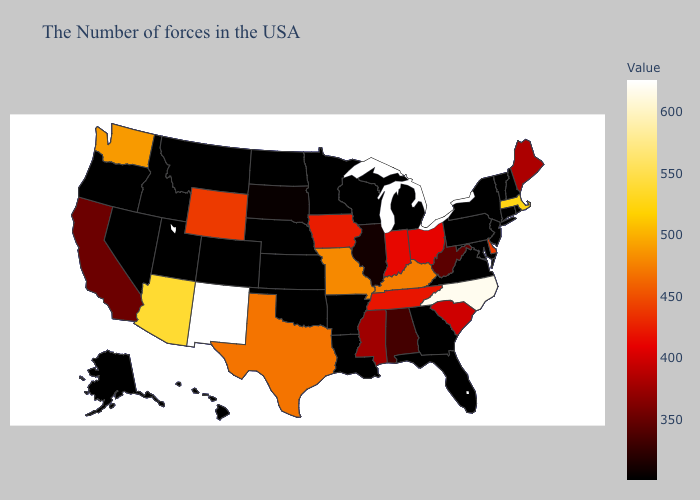Does Maine have the lowest value in the Northeast?
Write a very short answer. No. Does South Carolina have a lower value than Vermont?
Be succinct. No. Among the states that border New Jersey , which have the highest value?
Concise answer only. Delaware. Does Mississippi have a higher value than Oklahoma?
Concise answer only. Yes. Among the states that border Maryland , which have the highest value?
Short answer required. Delaware. Which states have the lowest value in the USA?
Be succinct. Rhode Island, New Hampshire, Vermont, Connecticut, New York, New Jersey, Maryland, Pennsylvania, Virginia, Florida, Georgia, Michigan, Wisconsin, Louisiana, Arkansas, Minnesota, Kansas, Nebraska, Oklahoma, North Dakota, Colorado, Utah, Montana, Idaho, Nevada, Oregon, Alaska, Hawaii. 